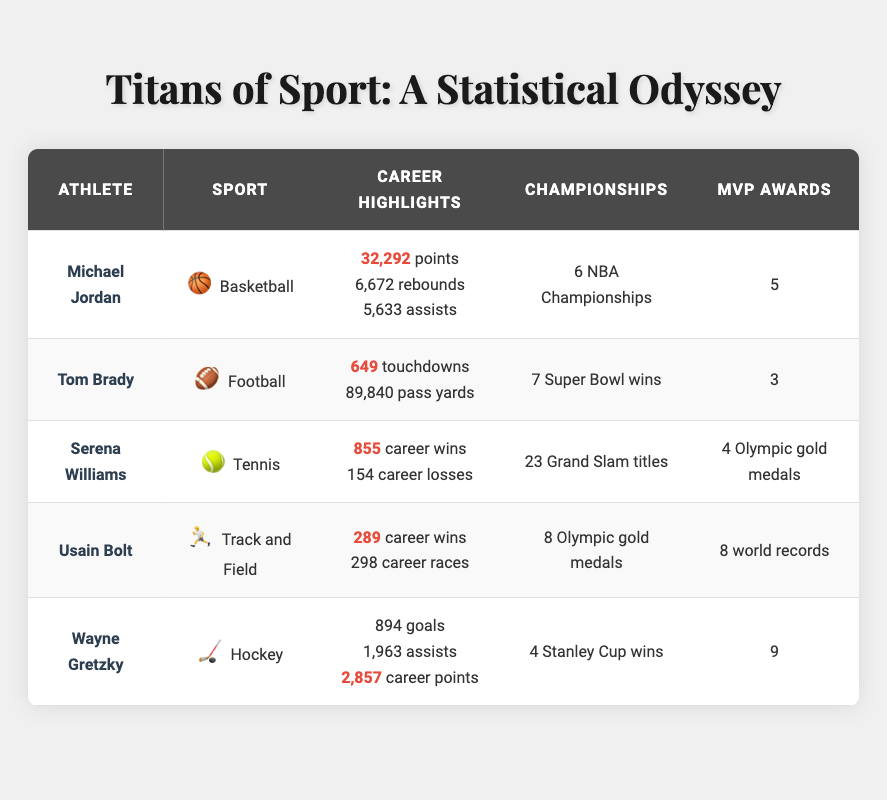What is the total number of championships won by all athletes listed in the table? To find the total number of championships, we need to add the championships won by each athlete: Michael Jordan (6) + Tom Brady (7) + Serena Williams (0) + Usain Bolt (0) + Wayne Gretzky (4) = 17. Note that Serena Williams and Usain Bolt do not have any championships listed for their sports.
Answer: 17 How many MVP awards did Wayne Gretzky win? The table directly lists the number of MVP awards associated with Wayne Gretzky, which is 9.
Answer: 9 Which athlete has the highest number of grand slam titles? By examining the table, we see that Serena Williams has 23 grand slam titles, which is the highest compared to others listed.
Answer: 23 Does Usain Bolt have more Olympic gold medals than Michael Jordan has NBA Championships? Usain Bolt has 8 Olympic gold medals while Michael Jordan has 6 NBA Championships. Since 8 is greater than 6, the statement is true.
Answer: Yes What is the average number of MVP awards among the athletes listed? To find the average, add up the MVP awards: Michael Jordan (5) + Tom Brady (3) + Serena Williams (0) + Usain Bolt (0) + Wayne Gretzky (9) = 17 and divide by the number of athletes (5). Thus, the average is 17/5 = 3.4.
Answer: 3.4 Which athlete holds the record for the most career points? The table shows that Michael Jordan has the highest career points with 32,292 points.
Answer: 32,292 How many total Olympic gold medals do both Usain Bolt and Serena Williams have combined? Usain Bolt has 8 Olympic gold medals and Serena Williams has 4. By summing these together: 8 + 4 = 12.
Answer: 12 Is it true that Tom Brady has more career touchdowns than Usain Bolt has career races? Tom Brady has 649 career touchdowns while Usain Bolt has 298 career races. Since 649 is greater than 298, the statement is true.
Answer: Yes 